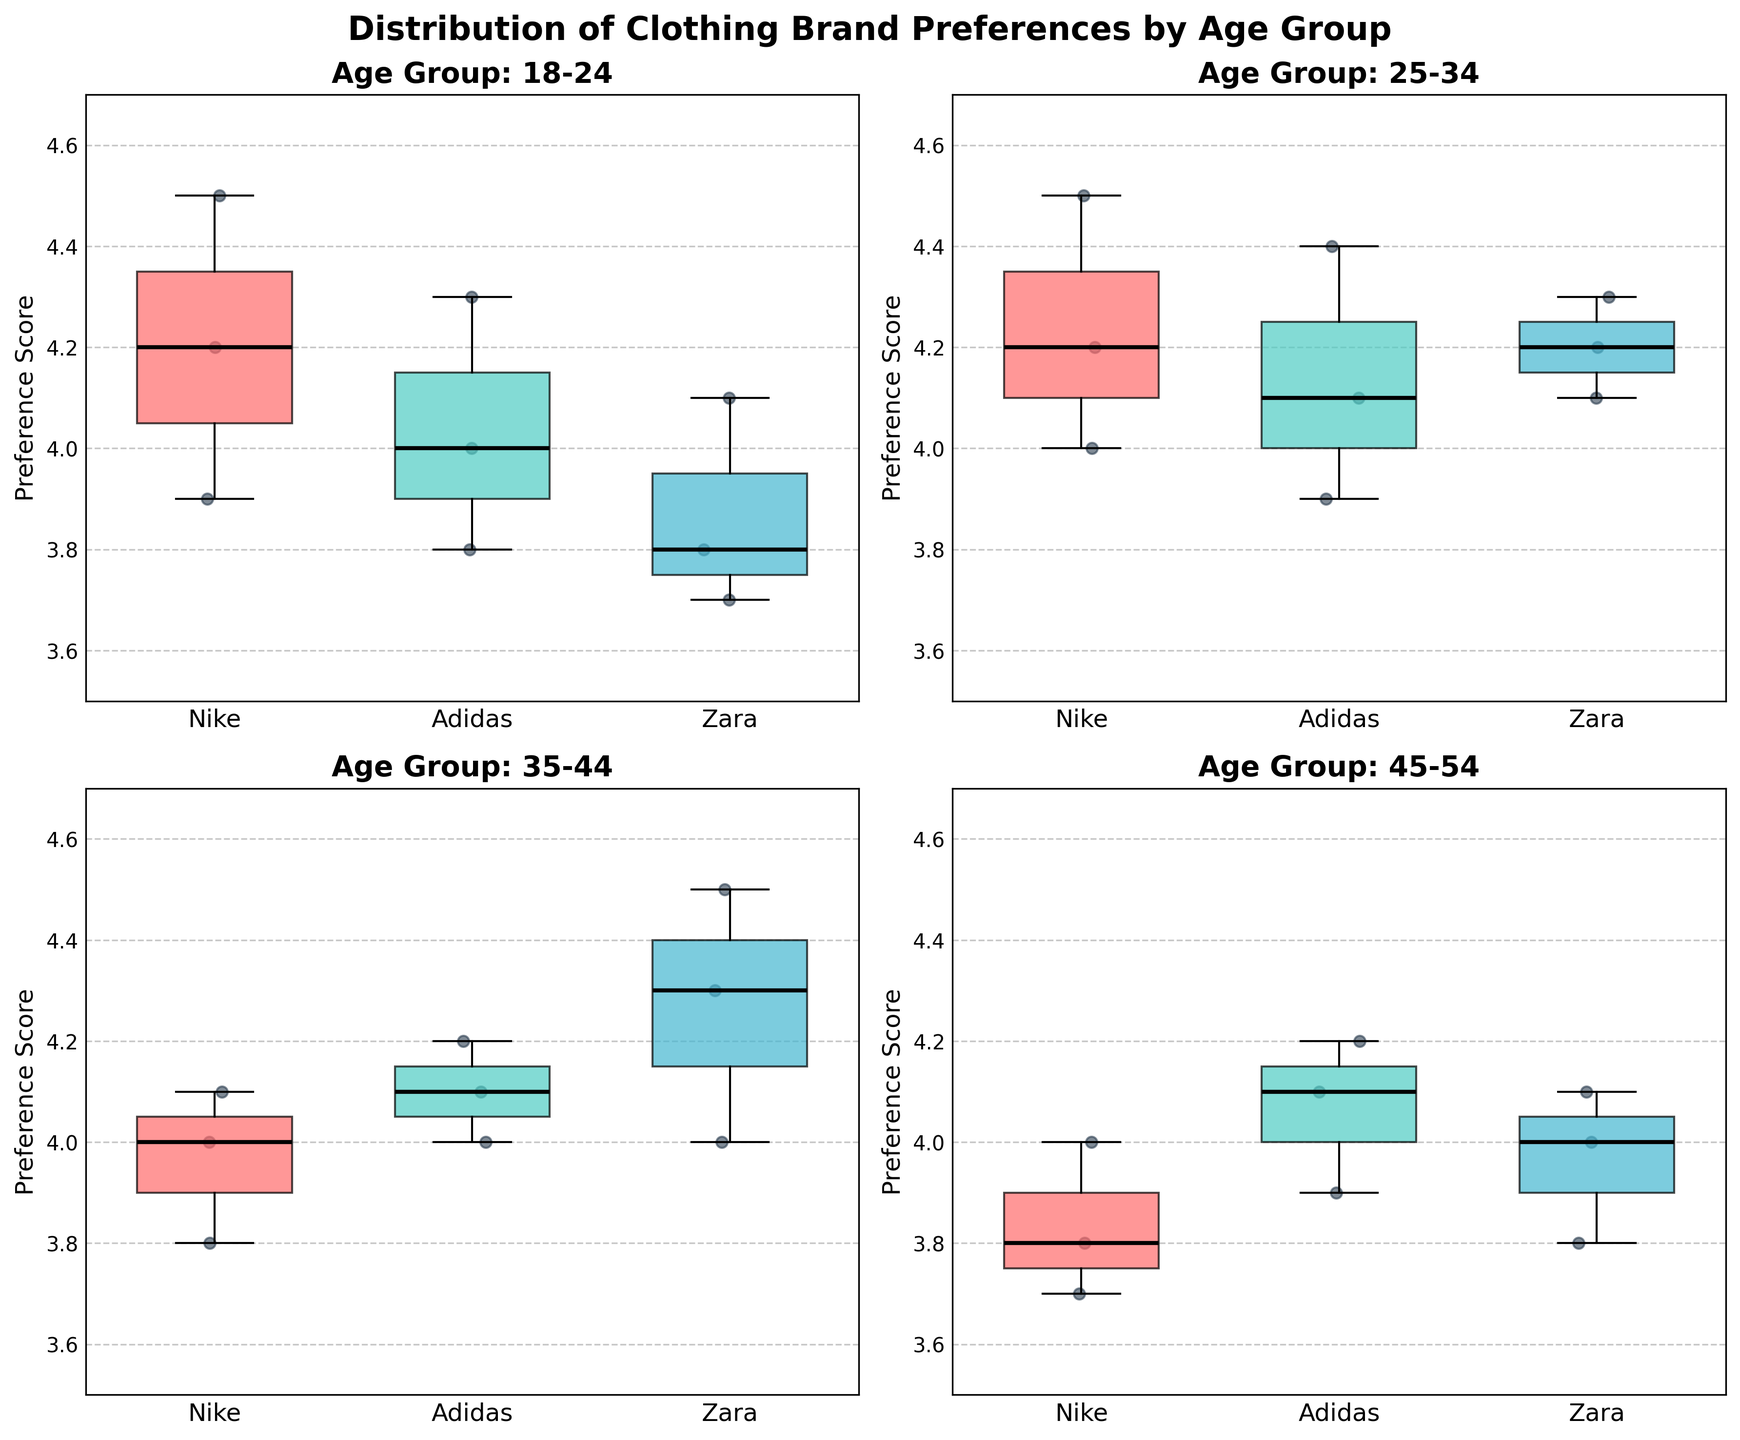What is the title of the figure? The title of the figure is displayed at the top of the plot. It reads "Distribution of Clothing Brand Preferences by Age Group".
Answer: Distribution of Clothing Brand Preferences by Age Group What brands are compared in the figure? The x-axis labels of each subplot indicate the brands being compared. They are Nike, Adidas, and Zara.
Answer: Nike, Adidas, Zara Which age group has the widest interquartile range (IQR) for Nike? The IQR is the range between the first quartile (Q1) and the third quartile (Q3). By comparing the width of the boxes for Nike in each subplot, the 18-24 age group has the widest IQR.
Answer: 18-24 What is the median preference score for Adidas in the 25-34 age group? The median is indicated by the horizontal line inside each box. For Adidas in the 25-34 age group, the median preference score appears to be 4.1.
Answer: 4.1 Which brand appears to have the most consistent preference scores across all age groups? The consistency of preference scores can be determined by the spread of the boxes. Adidas has relatively smaller boxes and whiskers across all age groups, indicating more consistent preference scores.
Answer: Adidas Between Nike and Zara, which brand has a higher median preference score in the 35-44 age group? By comparing the horizontal lines inside the boxes for Nike and Zara in the 35-44 age group, Zara has a higher median preference score.
Answer: Zara Which age group has the highest variability in preference scores for Zara? Variability can be observed by the height of the boxes and whiskers. The age group 35-44 shows the highest variability for Zara with a wider spread of scores.
Answer: 35-44 What is the range of preference scores for Nike in the 45-54 age group? The range is the difference between the minimum and maximum values. For Nike in the 45-54 age group, the range is from around 3.7 to 4.0.
Answer: 0.3 In the 18-24 age group, which brand has the lowest median preference score? By observing the horizontal lines inside the boxes in the 18-24 age group subplot, Zara has the lowest median preference score.
Answer: Zara Which brand has the highest overall mean preference score across all age groups? The mean is not explicitly shown, but by examining the central tendencies (median values) and the overall shifts, Nike appears to have the highest median scores across most age groups.
Answer: Nike 